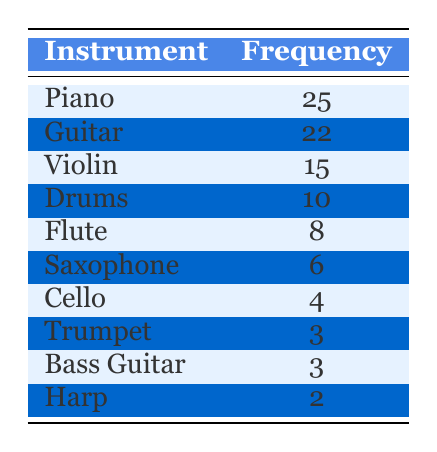What instrument has the highest frequency among recent music graduates? By looking at the frequency column, I see that the instrument with the highest frequency is listed at the top of the table, which is Piano with a frequency of 25.
Answer: Piano How many more graduates play the Piano than the Violin? According to the table, the frequency for Piano is 25 and for Violin is 15. The difference is calculated as 25 - 15 = 10.
Answer: 10 Is it true that more graduates play the Flute than the Saxophone? The frequency for Flute is 8 and for Saxophone is 6. Since 8 is greater than 6, the statement is true.
Answer: Yes What is the total number of graduates who play the Cello, Trumpet, and Harp? The frequencies are as follows: Cello has 4, Trumpet has 3, and Harp has 2. Adding them together gives 4 + 3 + 2 = 9.
Answer: 9 Which two instruments have the least frequency among recent music graduates? The instruments with the least frequency are identified by looking at the bottom of the table. The last two instruments are Trumpet (3) and Bass Guitar (3).
Answer: Trumpet and Bass Guitar What is the average frequency of instruments played by recent music graduates? First, I sum all the frequencies: (25 + 22 + 15 + 10 + 8 + 6 + 4 + 3 + 3 + 2) = 98. There are 10 instruments, so the average is 98 / 10 = 9.8.
Answer: 9.8 How many instruments have a frequency greater than 10? The instruments with frequencies greater than 10 are identified: Piano (25), Guitar (22), Violin (15), and Drums (10). Counting them gives a total of 4 instruments.
Answer: 4 If you combine the frequencies of the Guitar and Drums, how many graduates play those instruments? The frequency of Guitar is 22 and that of Drums is 10. Adding those gives 22 + 10 = 32.
Answer: 32 